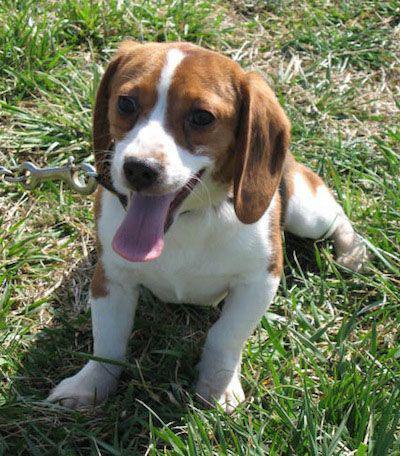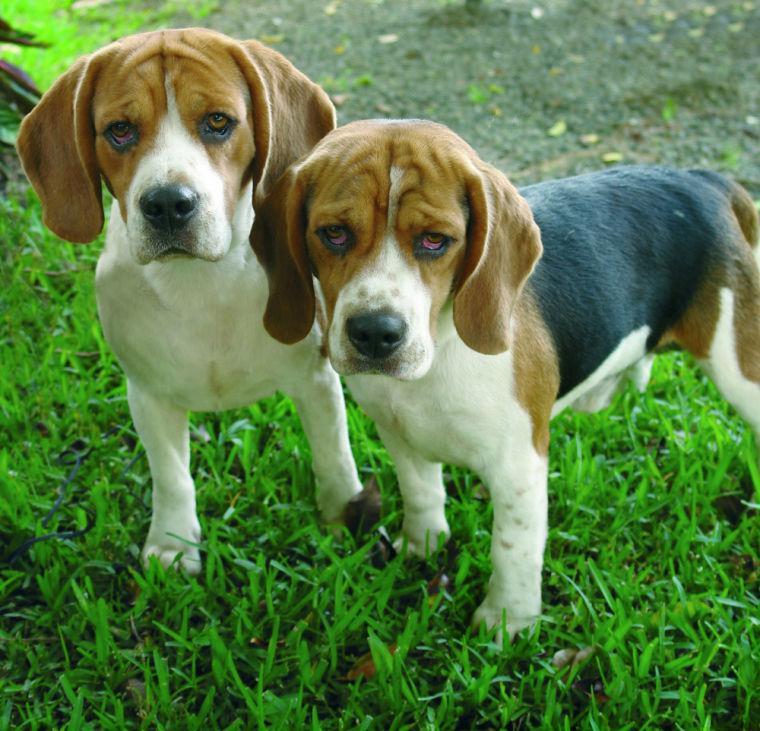The first image is the image on the left, the second image is the image on the right. Examine the images to the left and right. Is the description "One image contains twice as many beagles as the other, and the combined images total three dogs." accurate? Answer yes or no. Yes. The first image is the image on the left, the second image is the image on the right. Analyze the images presented: Is the assertion "The right image contains exactly two dogs." valid? Answer yes or no. Yes. 